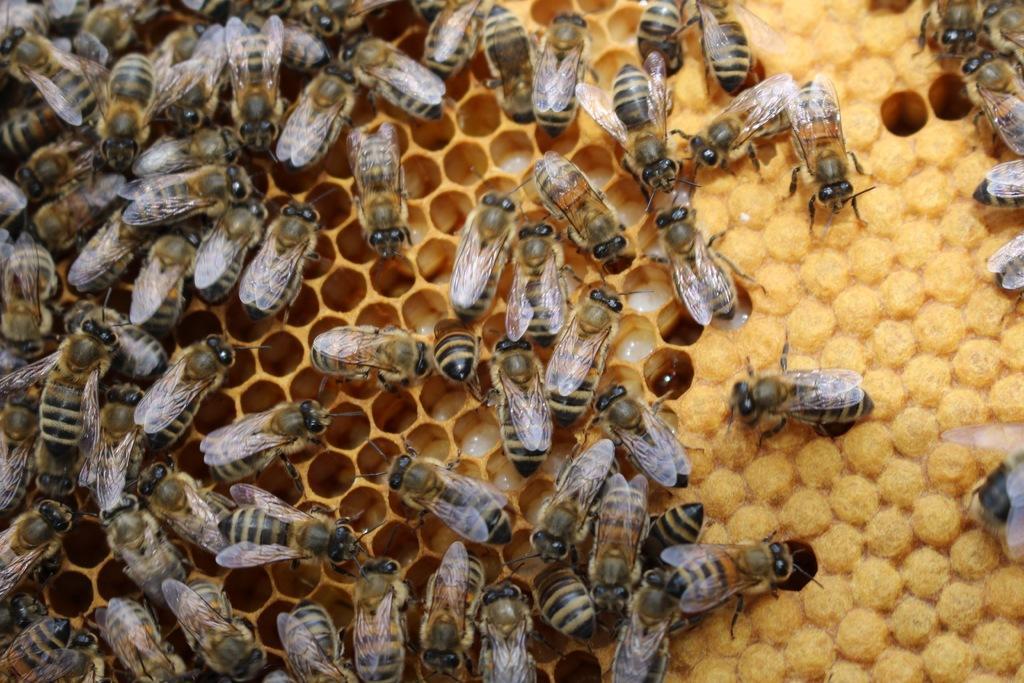Could you give a brief overview of what you see in this image? In the image there is a honeycomb with honey bees. 